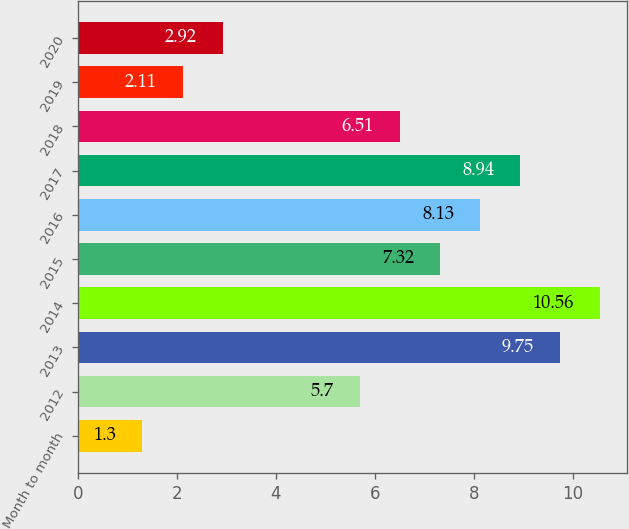<chart> <loc_0><loc_0><loc_500><loc_500><bar_chart><fcel>Month to month<fcel>2012<fcel>2013<fcel>2014<fcel>2015<fcel>2016<fcel>2017<fcel>2018<fcel>2019<fcel>2020<nl><fcel>1.3<fcel>5.7<fcel>9.75<fcel>10.56<fcel>7.32<fcel>8.13<fcel>8.94<fcel>6.51<fcel>2.11<fcel>2.92<nl></chart> 